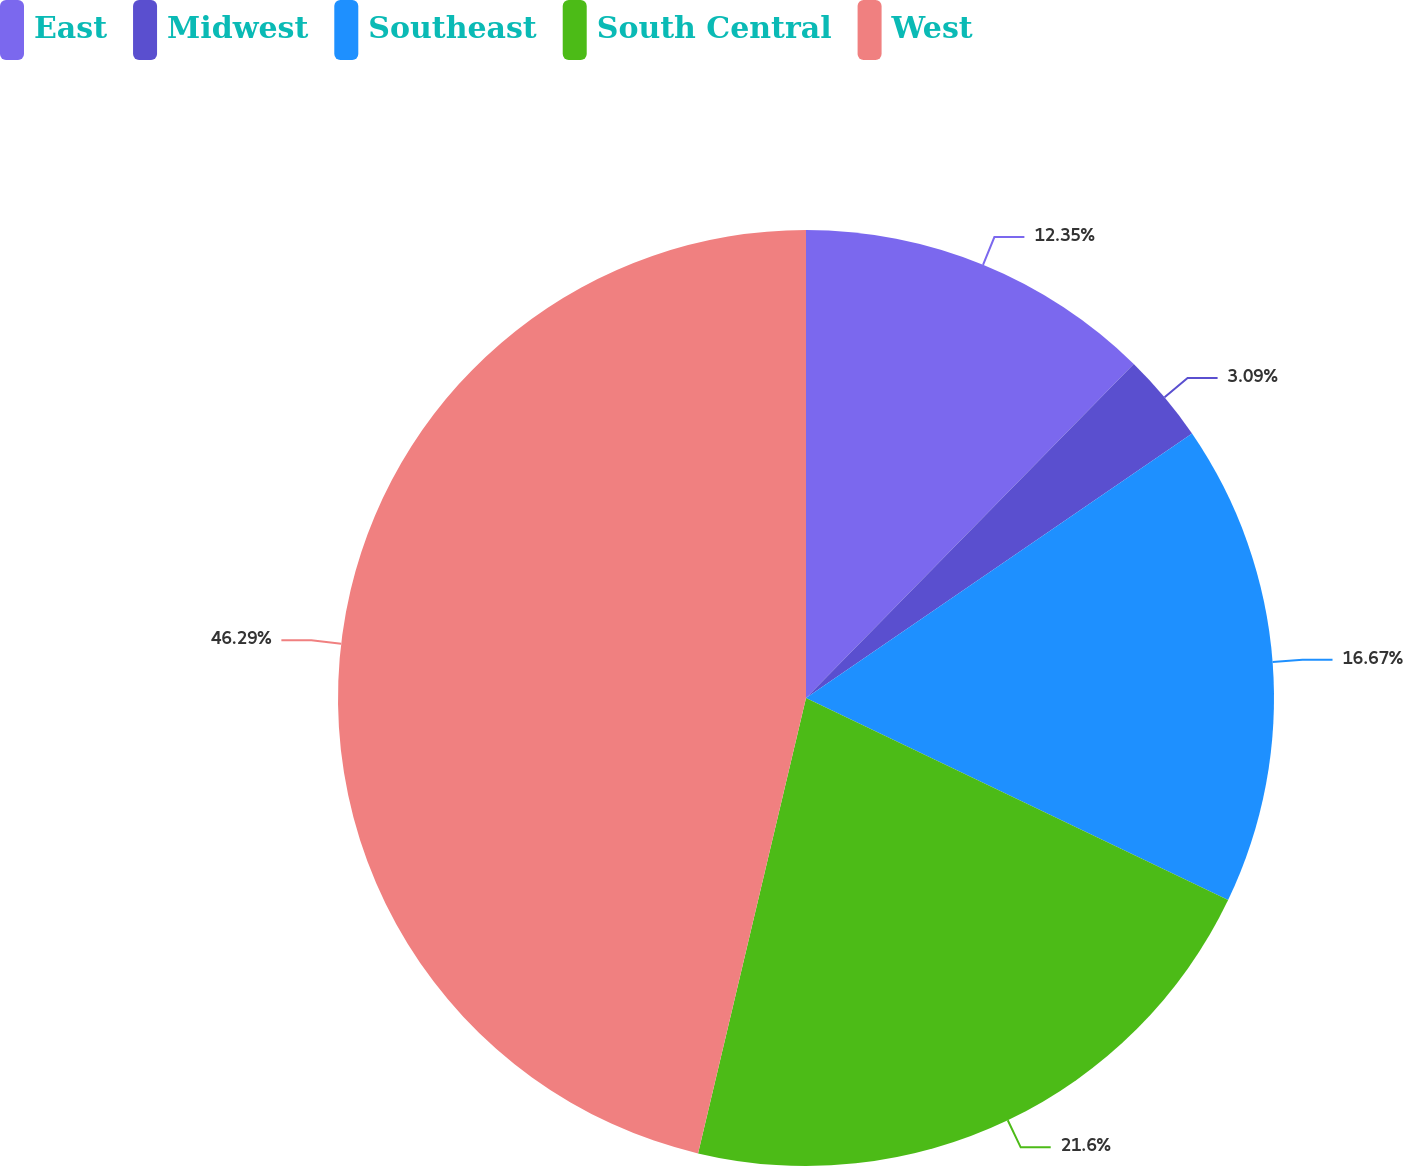Convert chart to OTSL. <chart><loc_0><loc_0><loc_500><loc_500><pie_chart><fcel>East<fcel>Midwest<fcel>Southeast<fcel>South Central<fcel>West<nl><fcel>12.35%<fcel>3.09%<fcel>16.67%<fcel>21.6%<fcel>46.3%<nl></chart> 